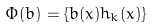Convert formula to latex. <formula><loc_0><loc_0><loc_500><loc_500>\Phi ( b ) = \{ b ( x ) h _ { k } ( x ) \}</formula> 